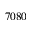Convert formula to latex. <formula><loc_0><loc_0><loc_500><loc_500>7 0 8 0</formula> 